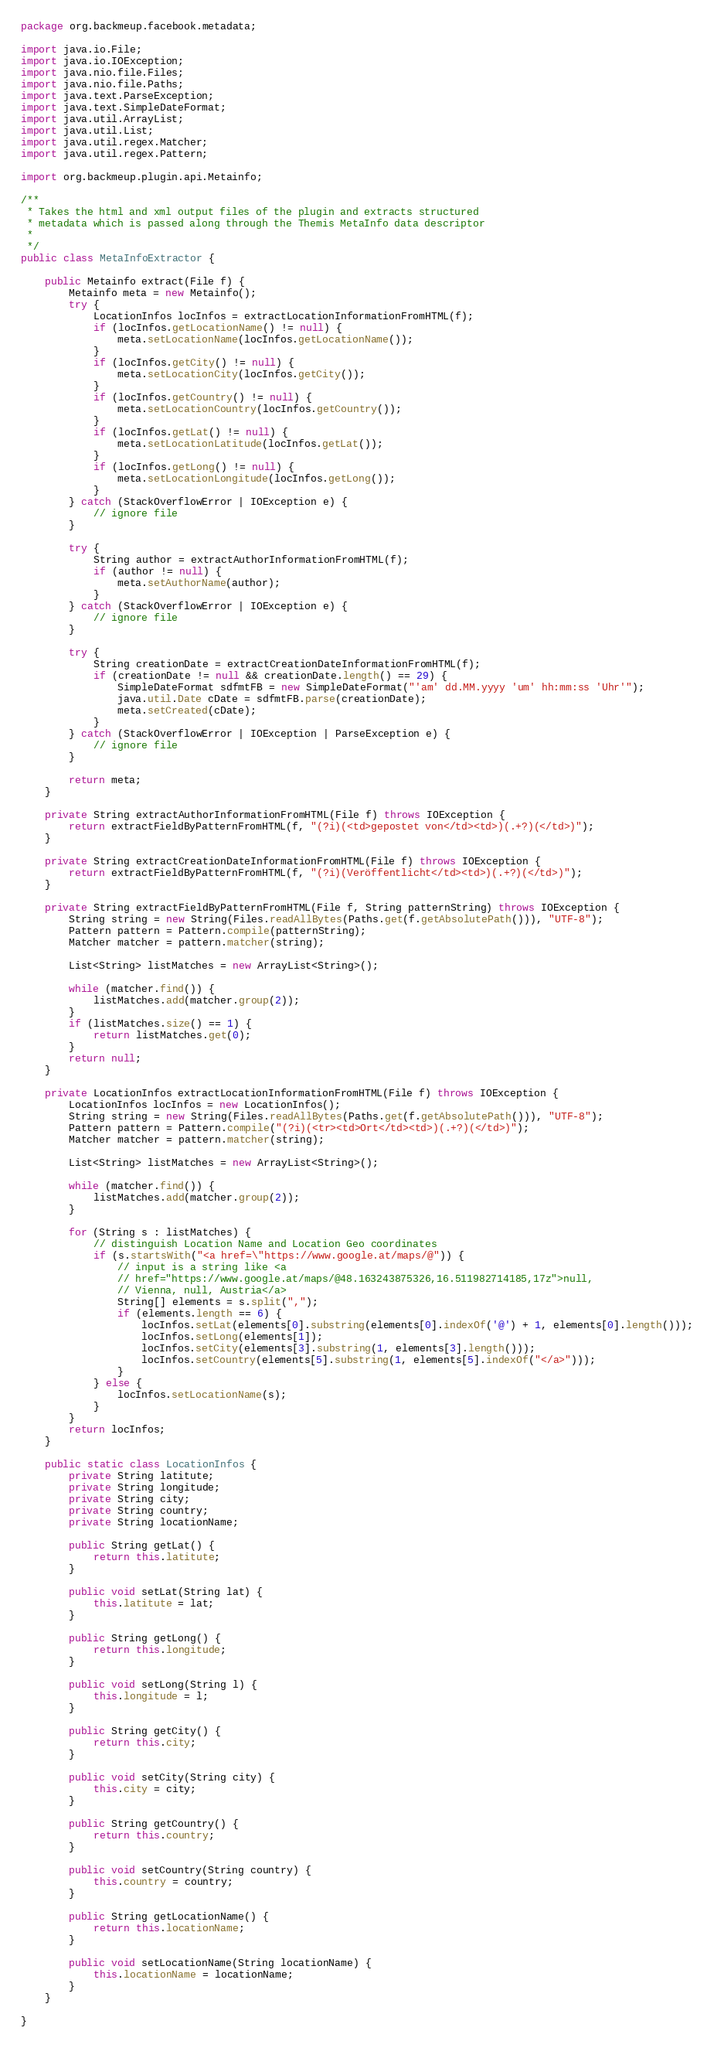<code> <loc_0><loc_0><loc_500><loc_500><_Java_>package org.backmeup.facebook.metadata;

import java.io.File;
import java.io.IOException;
import java.nio.file.Files;
import java.nio.file.Paths;
import java.text.ParseException;
import java.text.SimpleDateFormat;
import java.util.ArrayList;
import java.util.List;
import java.util.regex.Matcher;
import java.util.regex.Pattern;

import org.backmeup.plugin.api.Metainfo;

/**
 * Takes the html and xml output files of the plugin and extracts structured
 * metadata which is passed along through the Themis MetaInfo data descriptor
 *
 */
public class MetaInfoExtractor {

    public Metainfo extract(File f) {
        Metainfo meta = new Metainfo();
        try {
            LocationInfos locInfos = extractLocationInformationFromHTML(f);
            if (locInfos.getLocationName() != null) {
                meta.setLocationName(locInfos.getLocationName());
            }
            if (locInfos.getCity() != null) {
                meta.setLocationCity(locInfos.getCity());
            }
            if (locInfos.getCountry() != null) {
                meta.setLocationCountry(locInfos.getCountry());
            }
            if (locInfos.getLat() != null) {
                meta.setLocationLatitude(locInfos.getLat());
            }
            if (locInfos.getLong() != null) {
                meta.setLocationLongitude(locInfos.getLong());
            }
        } catch (StackOverflowError | IOException e) {
            // ignore file
        }

        try {
            String author = extractAuthorInformationFromHTML(f);
            if (author != null) {
                meta.setAuthorName(author);
            }
        } catch (StackOverflowError | IOException e) {
            // ignore file
        }

        try {
            String creationDate = extractCreationDateInformationFromHTML(f);
            if (creationDate != null && creationDate.length() == 29) {
                SimpleDateFormat sdfmtFB = new SimpleDateFormat("'am' dd.MM.yyyy 'um' hh:mm:ss 'Uhr'");
                java.util.Date cDate = sdfmtFB.parse(creationDate);
                meta.setCreated(cDate);
            }
        } catch (StackOverflowError | IOException | ParseException e) {
            // ignore file
        }

        return meta;
    }

    private String extractAuthorInformationFromHTML(File f) throws IOException {
        return extractFieldByPatternFromHTML(f, "(?i)(<td>gepostet von</td><td>)(.+?)(</td>)");
    }

    private String extractCreationDateInformationFromHTML(File f) throws IOException {
        return extractFieldByPatternFromHTML(f, "(?i)(Veröffentlicht</td><td>)(.+?)(</td>)");
    }

    private String extractFieldByPatternFromHTML(File f, String patternString) throws IOException {
        String string = new String(Files.readAllBytes(Paths.get(f.getAbsolutePath())), "UTF-8");
        Pattern pattern = Pattern.compile(patternString);
        Matcher matcher = pattern.matcher(string);

        List<String> listMatches = new ArrayList<String>();

        while (matcher.find()) {
            listMatches.add(matcher.group(2));
        }
        if (listMatches.size() == 1) {
            return listMatches.get(0);
        }
        return null;
    }

    private LocationInfos extractLocationInformationFromHTML(File f) throws IOException {
        LocationInfos locInfos = new LocationInfos();
        String string = new String(Files.readAllBytes(Paths.get(f.getAbsolutePath())), "UTF-8");
        Pattern pattern = Pattern.compile("(?i)(<tr><td>Ort</td><td>)(.+?)(</td>)");
        Matcher matcher = pattern.matcher(string);

        List<String> listMatches = new ArrayList<String>();

        while (matcher.find()) {
            listMatches.add(matcher.group(2));
        }

        for (String s : listMatches) {
            // distinguish Location Name and Location Geo coordinates
            if (s.startsWith("<a href=\"https://www.google.at/maps/@")) {
                // input is a string like <a
                // href="https://www.google.at/maps/@48.163243875326,16.511982714185,17z">null,
                // Vienna, null, Austria</a>
                String[] elements = s.split(",");
                if (elements.length == 6) {
                    locInfos.setLat(elements[0].substring(elements[0].indexOf('@') + 1, elements[0].length()));
                    locInfos.setLong(elements[1]);
                    locInfos.setCity(elements[3].substring(1, elements[3].length()));
                    locInfos.setCountry(elements[5].substring(1, elements[5].indexOf("</a>")));
                }
            } else {
                locInfos.setLocationName(s);
            }
        }
        return locInfos;
    }

    public static class LocationInfos {
        private String latitute;
        private String longitude;
        private String city;
        private String country;
        private String locationName;

        public String getLat() {
            return this.latitute;
        }

        public void setLat(String lat) {
            this.latitute = lat;
        }

        public String getLong() {
            return this.longitude;
        }

        public void setLong(String l) {
            this.longitude = l;
        }

        public String getCity() {
            return this.city;
        }

        public void setCity(String city) {
            this.city = city;
        }

        public String getCountry() {
            return this.country;
        }

        public void setCountry(String country) {
            this.country = country;
        }

        public String getLocationName() {
            return this.locationName;
        }

        public void setLocationName(String locationName) {
            this.locationName = locationName;
        }
    }

}
</code> 